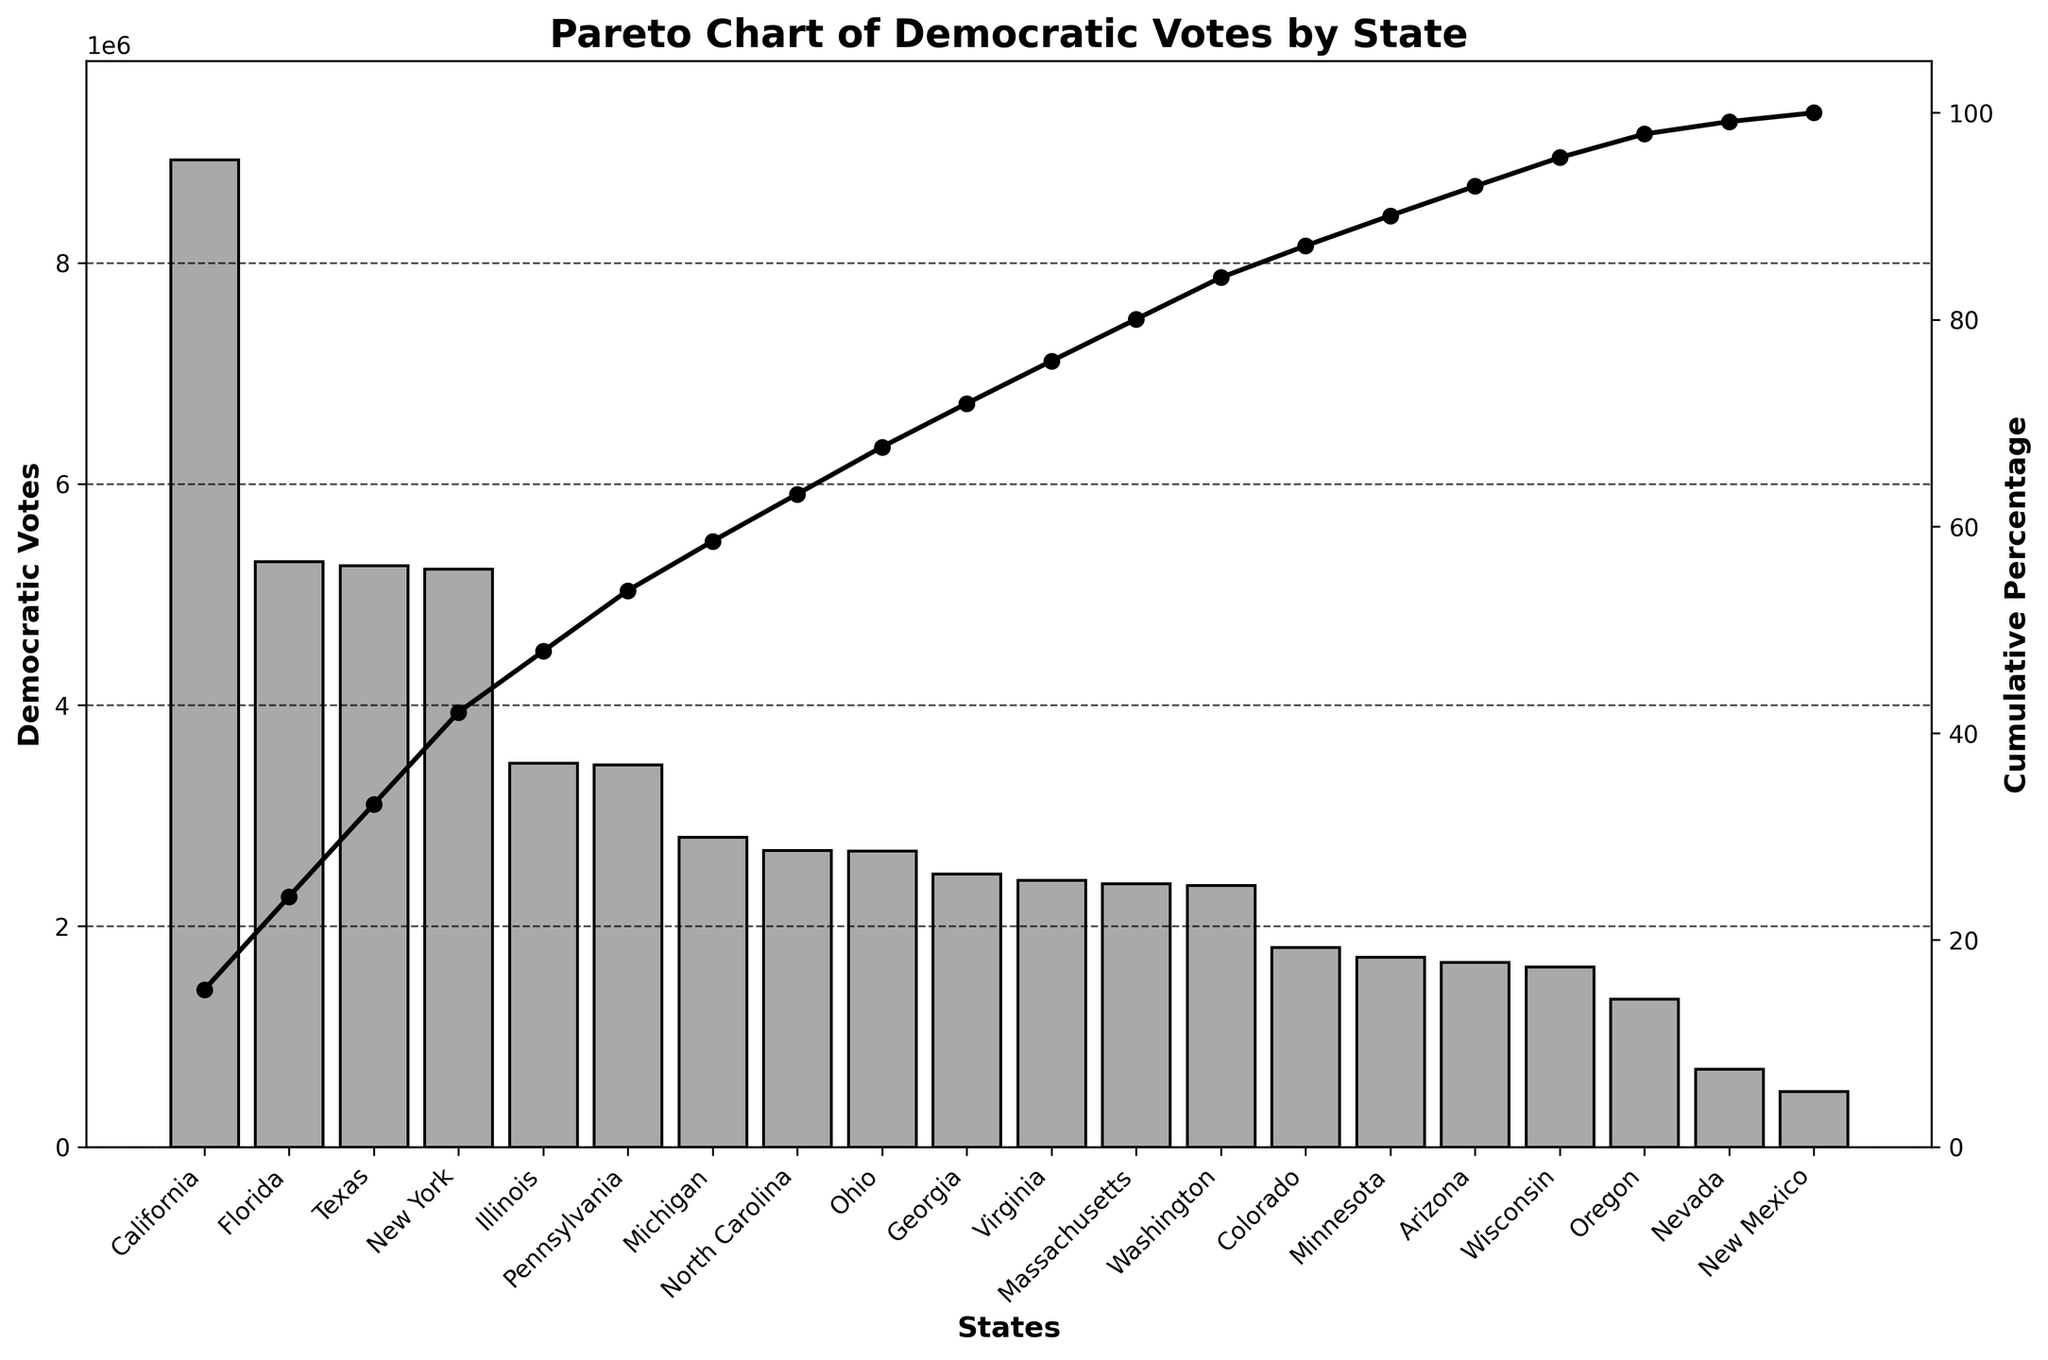What's the title of the chart? The title is found at the top center of the chart, written in bold and larger font size compared to other texts.
Answer: Pareto Chart of Democratic Votes by State Which state has the highest number of Democratic votes? The state with the highest number of Democratic votes will have the tallest bar in the bar chart portion of the Pareto chart.
Answer: California What is the range of Democratic votes on the y-axis? The y-axis on the left shows the range of Democratic votes. Look at the labels from the bottom to the top of this axis.
Answer: 0 to approximately 9,832,000 Which states are responsible for reaching the cumulative percentage of around 50%? To find this, follow the cumulative percentage line (black line with marker 'o') until it reaches around 50% on the right y-axis. The states before this point will add up to about 50%.
Answer: California, Texas, Florida What's the cumulative percentage after the first three states? Look at the cumulative percentage line after the third state, which is Florida. Refer to the corresponding value on the right y-axis.
Answer: Approximately 50% Comparing Illinois and Ohio, which state has more Democratic votes? Find the bars representing Illinois and Ohio; the taller bar between the two states indicates more Democratic votes.
Answer: Illinois What is the cumulative percentage contributed by New York alone? Once you locate New York on the x-axis, follow the cumulative percentage line above it and read the value from the right y-axis.
Answer: Approximately 38% Are there any states with a cumulative percentage contribution greater than 100%? The cumulative percentage line should not exceed 100% as it represents a sum total that reaches 100%.
Answer: No How many states are depicted in this Pareto chart? Count the number of bars along the x-axis, each bar representing a state.
Answer: 20 